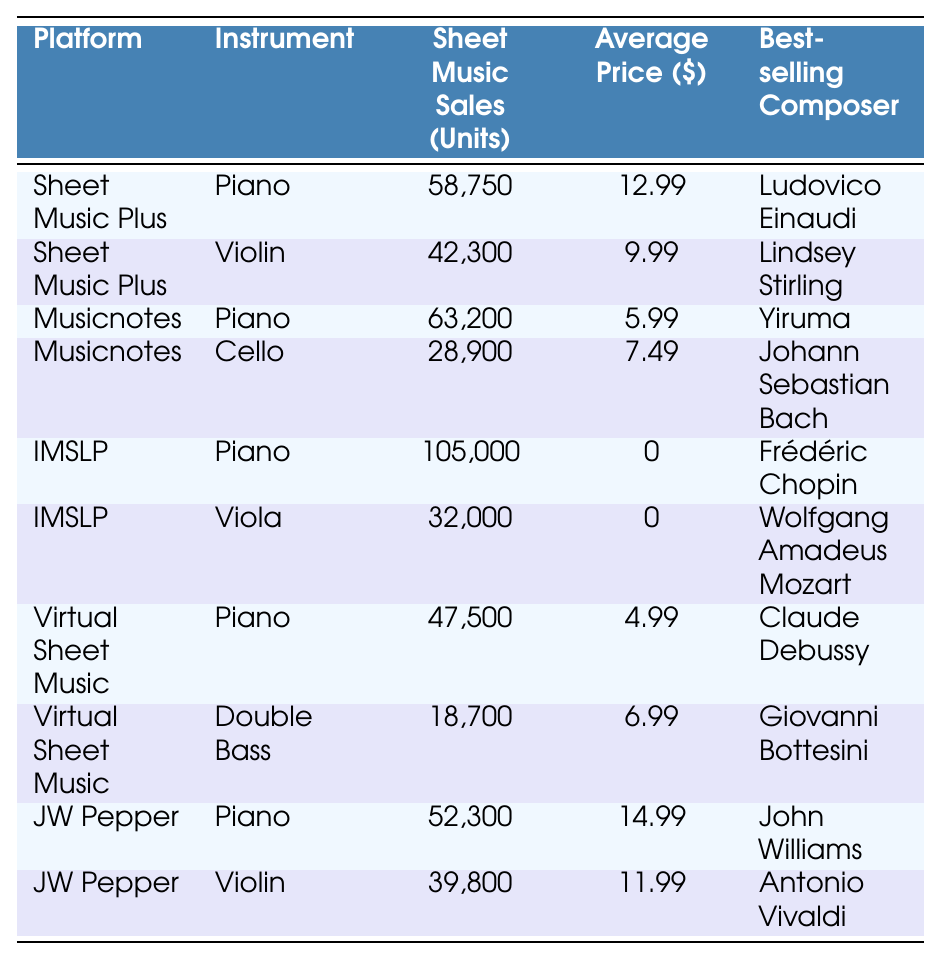What is the best-selling composer for piano sheet music on IMSLP? The entry for IMSLP under the piano instrument lists Frédéric Chopin as the best-selling composer.
Answer: Frédéric Chopin Which platform has the highest sheet music sales for piano? The data shows that IMSLP has the highest sales figures with 105,000 units sold for piano.
Answer: IMSLP What is the average price of sheet music for violin on JW Pepper? The table lists the average price for violin sheet music on JW Pepper as $11.99.
Answer: $11.99 How many units of cello sheet music were sold on Musicnotes? According to the table, Musicnotes sold 28,900 units of cello sheet music.
Answer: 28,900 What is the total number of piano sheet music sales across all platforms? Summing up all piano sales gives: 58,750 + 63,200 + 105,000 + 47,500 + 52,300 = 326,750 total units sold for piano.
Answer: 326,750 Is the average price of violin sheet music higher on Sheet Music Plus than on JW Pepper? The average price for violin on Sheet Music Plus is $9.99, while on JW Pepper it's $11.99, indicating that JW Pepper's price is higher.
Answer: Yes Which instrument had the least sheet music sales across all platforms? Looking at the data, Double Bass from Virtual Sheet Music had the least sales at 18,700 units.
Answer: Double Bass Which platform has the lowest average price for piano sheet music? The Virtual Sheet Music entry shows the lowest average price for piano sheet music at $4.99.
Answer: Virtual Sheet Music What is the total revenue generated from cello sheet music sales on Musicnotes? Since the average price for cello sheet music is $7.49 and the units sold are 28,900, the total revenue is 7.49 * 28,900 = $216,661.
Answer: $216,661 If we only consider piano sheet music, which platform has the second highest sales? From the data, Musicnotes with 63,200 units stands as the second highest after IMSLP.
Answer: Musicnotes 